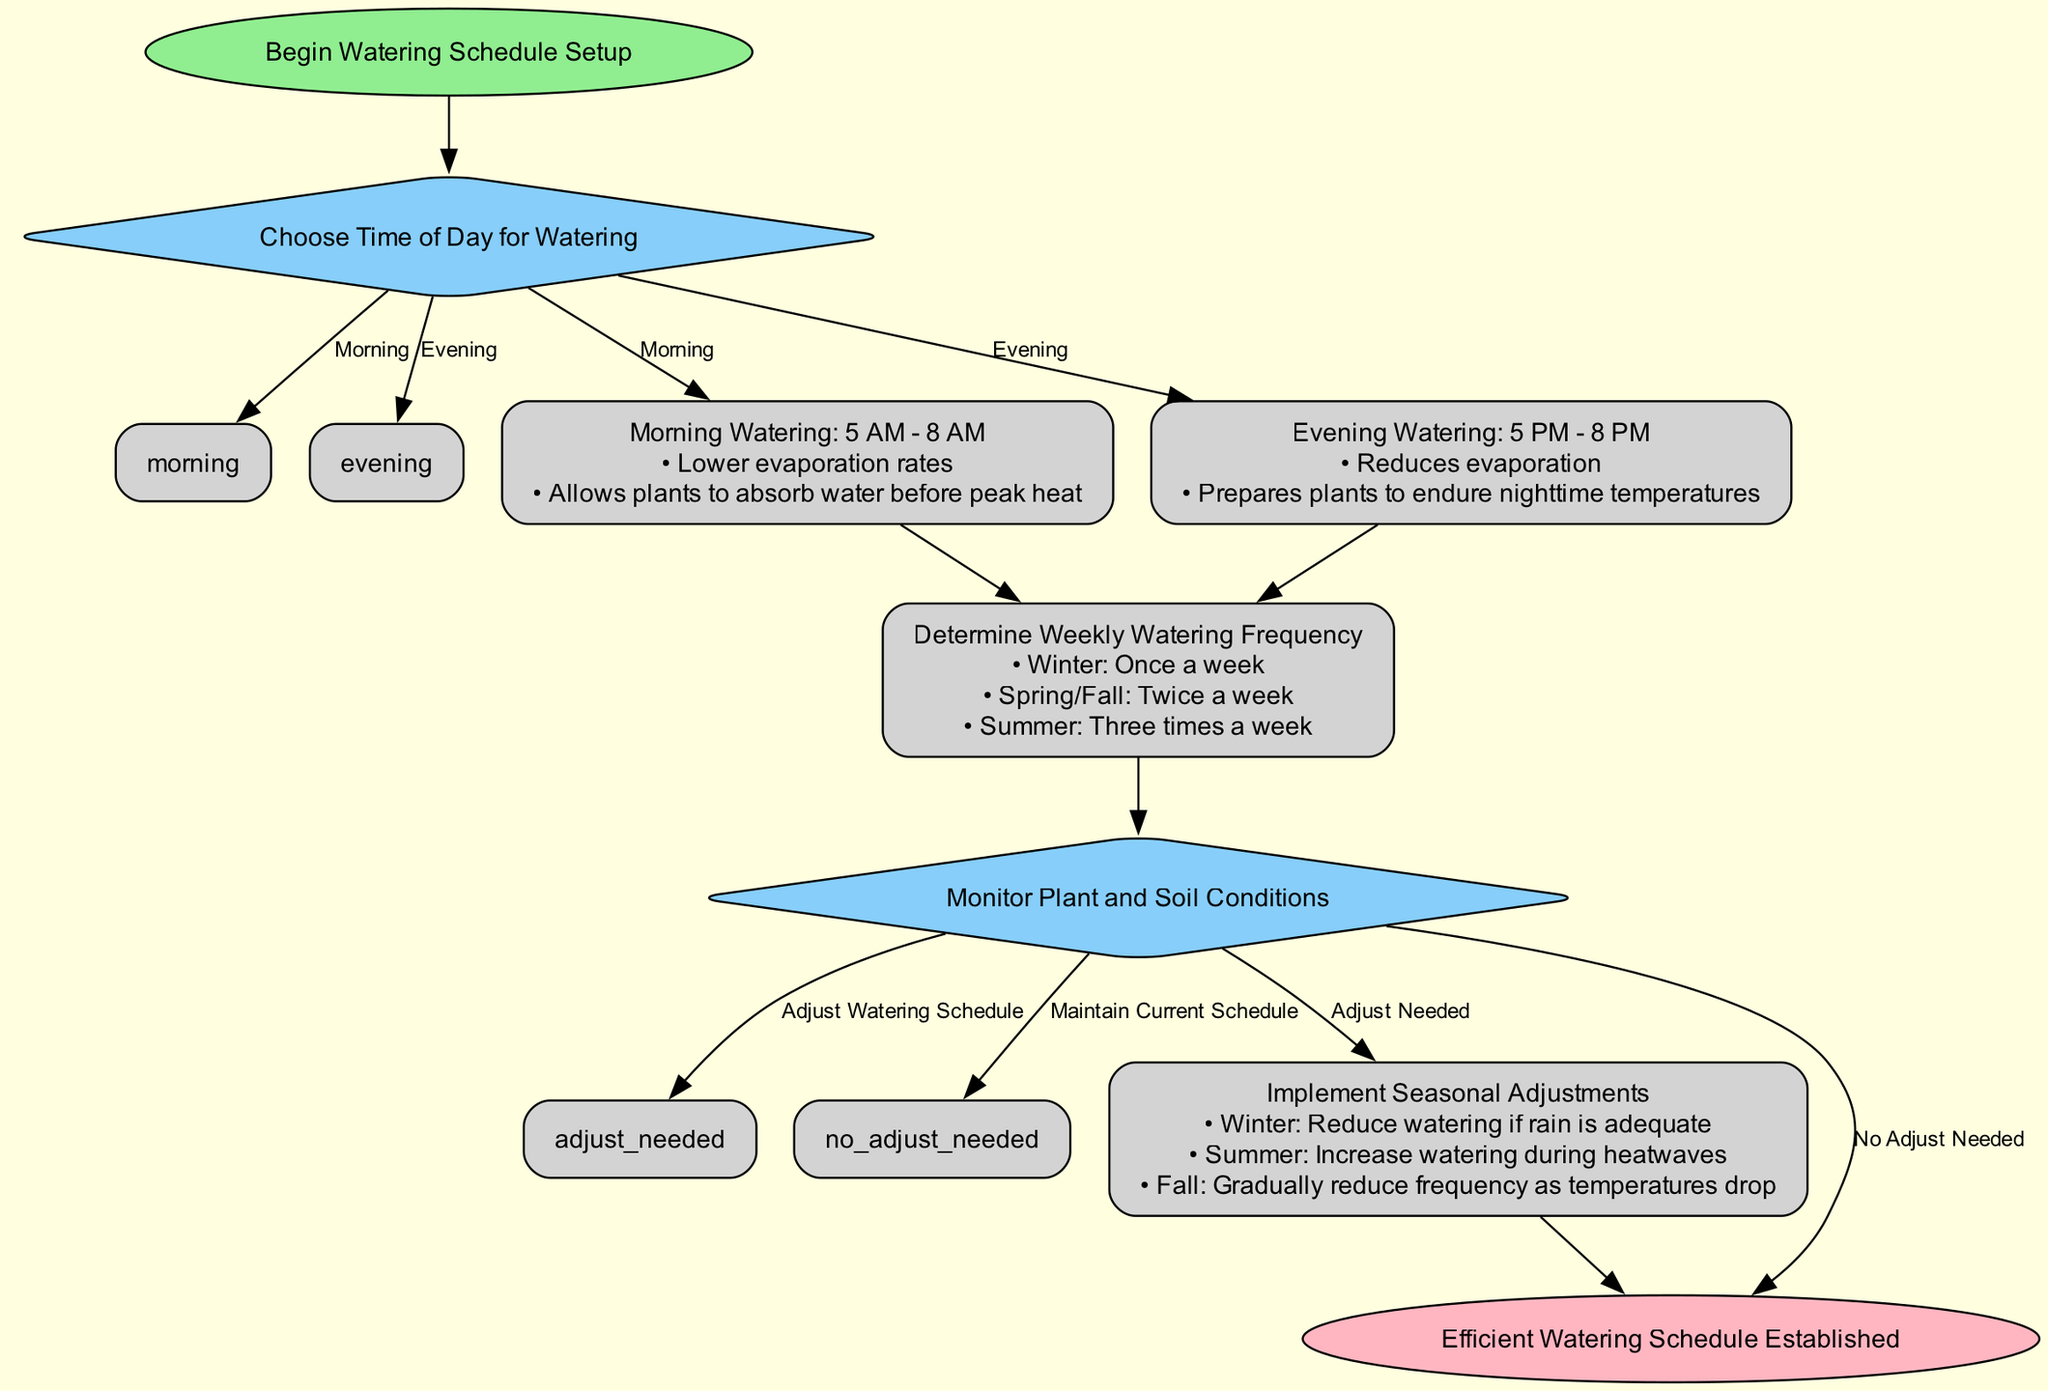What is the first step in the diagram? The first step in the diagram is labeled "Begin Watering Schedule Setup." It is designated as the start node, which initiates the flow of the process.
Answer: Begin Watering Schedule Setup How many watering time options are available? The diagram presents two distinct options for watering time: Morning and Evening. This can be determined from the decision node labeled "Choose Time of Day for Watering."
Answer: 2 What are the optimal hours for morning watering? The optimal hours for morning watering are indicated in the process node that states "Morning Watering: 5 AM - 8 AM." This information is clearly described in the flow for that specific watering time.
Answer: 5 AM - 8 AM What should you do if the plant and soil conditions indicate adjustment is needed? If adjustments are required based on monitoring plant and soil conditions, the next step, according to the flow, would be to adjust the watering schedule. This is specified in the decision node "Monitor Plant and Soil Conditions."
Answer: Adjust Watering Schedule How frequently should you water the plants in the summer? According to the diagram in the process node "Determine Weekly Watering Frequency," it is stated that watering should occur three times a week during the summer season. This frequency is clearly outlined.
Answer: Three times a week What happens if no adjustment is needed after monitoring? If no adjustments are needed, you would maintain the current watering schedule. This is indicated in the decision node leading to the end after the "Monitor Plant and Soil Conditions."
Answer: Maintain Current Schedule In which season should watering be reduced if rain is adequate? The diagram specifies in the seasonal adjustments process that watering should be reduced in the winter if rain is adequate, directly addressing the seasonal watering adjustments.
Answer: Winter At what time should evening watering take place? Evening watering is specified in the diagram as taking place between 5 PM and 8 PM, as outlined in the relevant process node for evening watering.
Answer: 5 PM - 8 PM 